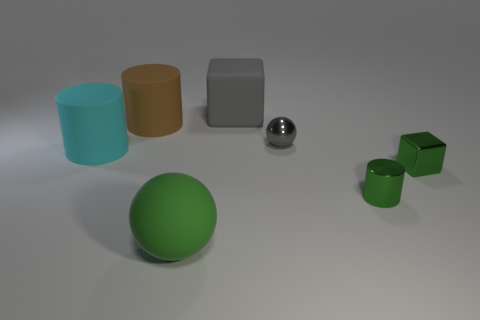Subtract all small green metal cylinders. How many cylinders are left? 2 Add 1 green cylinders. How many objects exist? 8 Subtract all cylinders. How many objects are left? 4 Subtract 1 cylinders. How many cylinders are left? 2 Subtract all red cylinders. Subtract all yellow balls. How many cylinders are left? 3 Add 2 big matte balls. How many big matte balls are left? 3 Add 5 big green matte spheres. How many big green matte spheres exist? 6 Subtract 0 blue cylinders. How many objects are left? 7 Subtract all gray matte blocks. Subtract all tiny shiny objects. How many objects are left? 3 